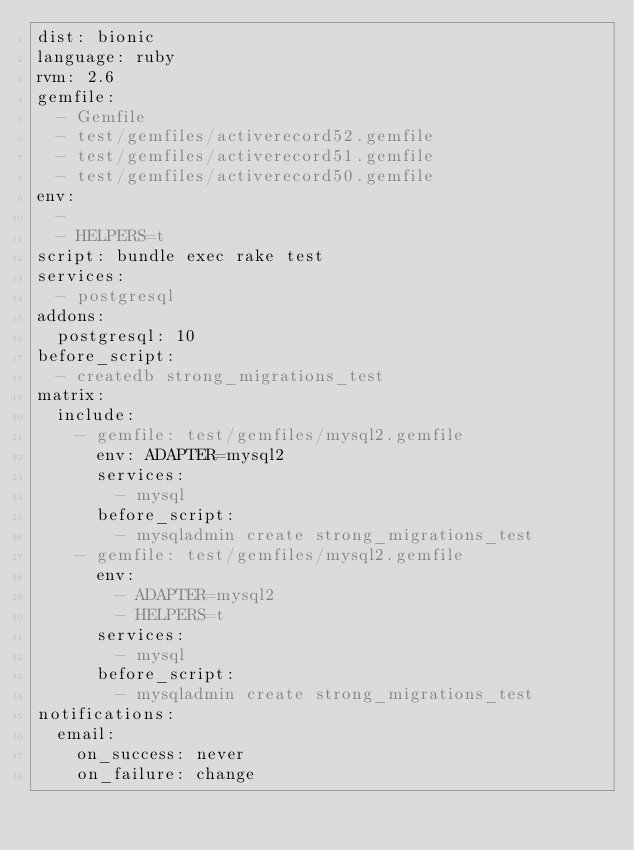<code> <loc_0><loc_0><loc_500><loc_500><_YAML_>dist: bionic
language: ruby
rvm: 2.6
gemfile:
  - Gemfile
  - test/gemfiles/activerecord52.gemfile
  - test/gemfiles/activerecord51.gemfile
  - test/gemfiles/activerecord50.gemfile
env:
  -
  - HELPERS=t
script: bundle exec rake test
services:
  - postgresql
addons:
  postgresql: 10
before_script:
  - createdb strong_migrations_test
matrix:
  include:
    - gemfile: test/gemfiles/mysql2.gemfile
      env: ADAPTER=mysql2
      services:
        - mysql
      before_script:
        - mysqladmin create strong_migrations_test
    - gemfile: test/gemfiles/mysql2.gemfile
      env:
        - ADAPTER=mysql2
        - HELPERS=t
      services:
        - mysql
      before_script:
        - mysqladmin create strong_migrations_test
notifications:
  email:
    on_success: never
    on_failure: change
</code> 